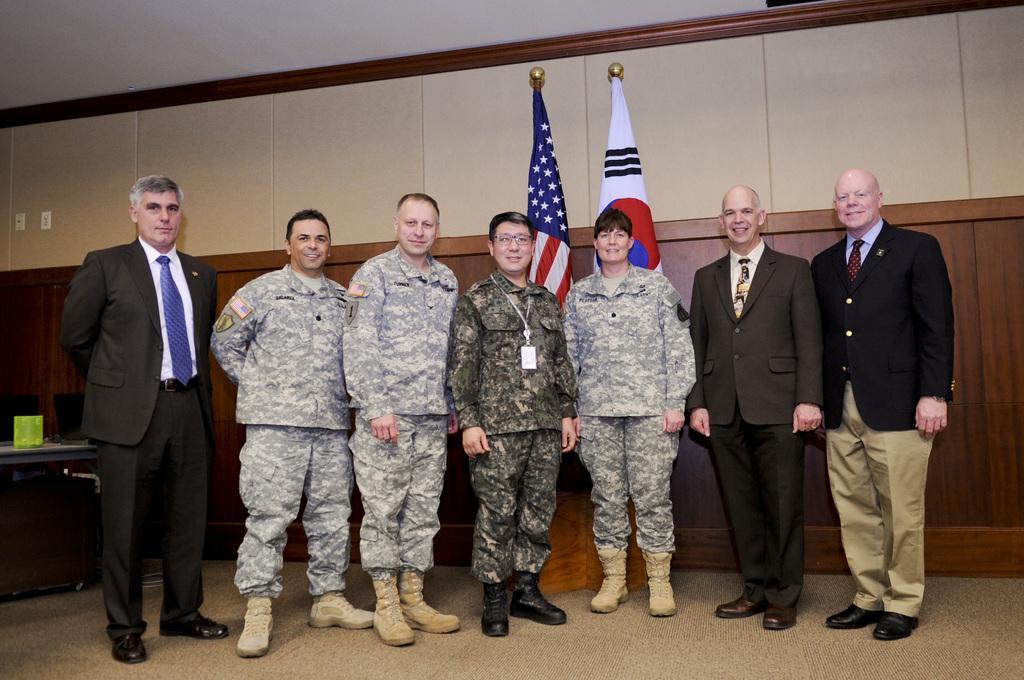Can you describe this image briefly? In this image we can see the people wearing the uniforms and standing. We can also see the men wearing the suits and standing and smiling. In the background we can see the flags, wall and also the ceiling. On the left we can see an object on the table. We can also see the chairs and also the switch boards. 